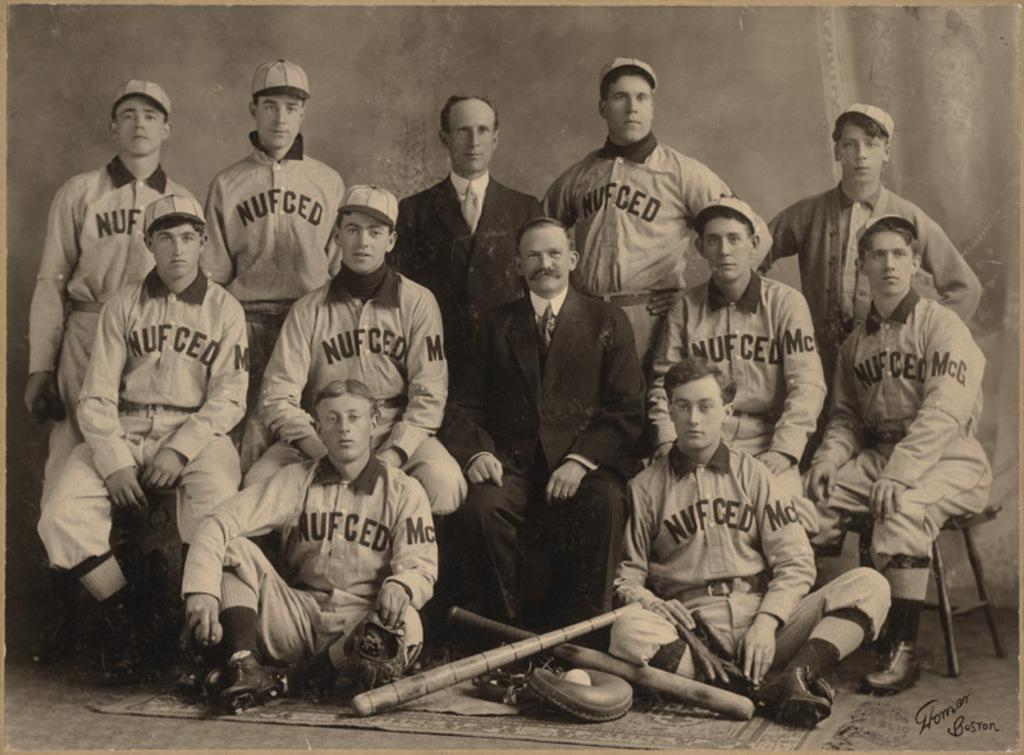Provide a one-sentence caption for the provided image. Team photo with the word "NUFCED" on the front. 